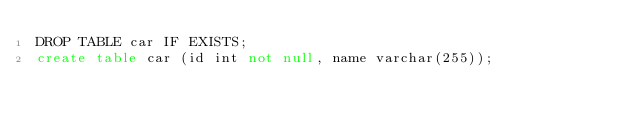Convert code to text. <code><loc_0><loc_0><loc_500><loc_500><_SQL_>DROP TABLE car IF EXISTS;
create table car (id int not null, name varchar(255));</code> 